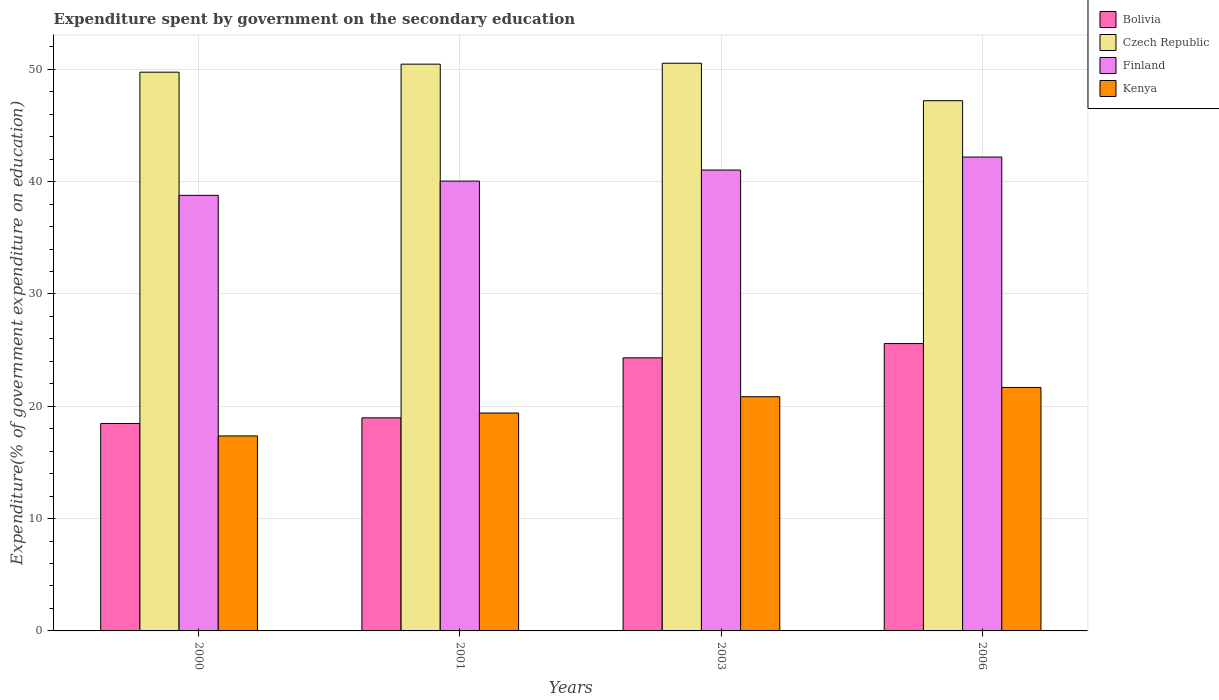How many groups of bars are there?
Offer a very short reply. 4. Are the number of bars per tick equal to the number of legend labels?
Make the answer very short. Yes. Are the number of bars on each tick of the X-axis equal?
Your answer should be very brief. Yes. How many bars are there on the 2nd tick from the left?
Keep it short and to the point. 4. How many bars are there on the 3rd tick from the right?
Offer a terse response. 4. In how many cases, is the number of bars for a given year not equal to the number of legend labels?
Keep it short and to the point. 0. What is the expenditure spent by government on the secondary education in Finland in 2006?
Make the answer very short. 42.19. Across all years, what is the maximum expenditure spent by government on the secondary education in Finland?
Keep it short and to the point. 42.19. Across all years, what is the minimum expenditure spent by government on the secondary education in Finland?
Make the answer very short. 38.78. In which year was the expenditure spent by government on the secondary education in Kenya maximum?
Provide a succinct answer. 2006. In which year was the expenditure spent by government on the secondary education in Finland minimum?
Provide a short and direct response. 2000. What is the total expenditure spent by government on the secondary education in Finland in the graph?
Keep it short and to the point. 162.06. What is the difference between the expenditure spent by government on the secondary education in Finland in 2000 and that in 2006?
Give a very brief answer. -3.41. What is the difference between the expenditure spent by government on the secondary education in Kenya in 2003 and the expenditure spent by government on the secondary education in Czech Republic in 2006?
Offer a terse response. -26.36. What is the average expenditure spent by government on the secondary education in Bolivia per year?
Your answer should be very brief. 21.84. In the year 2000, what is the difference between the expenditure spent by government on the secondary education in Kenya and expenditure spent by government on the secondary education in Finland?
Offer a terse response. -21.42. What is the ratio of the expenditure spent by government on the secondary education in Czech Republic in 2003 to that in 2006?
Your response must be concise. 1.07. What is the difference between the highest and the second highest expenditure spent by government on the secondary education in Bolivia?
Provide a succinct answer. 1.27. What is the difference between the highest and the lowest expenditure spent by government on the secondary education in Finland?
Provide a short and direct response. 3.41. In how many years, is the expenditure spent by government on the secondary education in Kenya greater than the average expenditure spent by government on the secondary education in Kenya taken over all years?
Give a very brief answer. 2. Is the sum of the expenditure spent by government on the secondary education in Finland in 2000 and 2006 greater than the maximum expenditure spent by government on the secondary education in Czech Republic across all years?
Your answer should be compact. Yes. What does the 3rd bar from the left in 2001 represents?
Provide a short and direct response. Finland. What does the 1st bar from the right in 2003 represents?
Offer a terse response. Kenya. How many bars are there?
Keep it short and to the point. 16. Are all the bars in the graph horizontal?
Give a very brief answer. No. How many years are there in the graph?
Keep it short and to the point. 4. Are the values on the major ticks of Y-axis written in scientific E-notation?
Offer a terse response. No. Where does the legend appear in the graph?
Ensure brevity in your answer.  Top right. How many legend labels are there?
Your response must be concise. 4. How are the legend labels stacked?
Offer a terse response. Vertical. What is the title of the graph?
Provide a short and direct response. Expenditure spent by government on the secondary education. Does "Lao PDR" appear as one of the legend labels in the graph?
Keep it short and to the point. No. What is the label or title of the Y-axis?
Your answer should be very brief. Expenditure(% of government expenditure on education). What is the Expenditure(% of government expenditure on education) in Bolivia in 2000?
Offer a very short reply. 18.47. What is the Expenditure(% of government expenditure on education) of Czech Republic in 2000?
Offer a very short reply. 49.75. What is the Expenditure(% of government expenditure on education) of Finland in 2000?
Provide a short and direct response. 38.78. What is the Expenditure(% of government expenditure on education) in Kenya in 2000?
Your response must be concise. 17.36. What is the Expenditure(% of government expenditure on education) of Bolivia in 2001?
Keep it short and to the point. 18.97. What is the Expenditure(% of government expenditure on education) of Czech Republic in 2001?
Keep it short and to the point. 50.46. What is the Expenditure(% of government expenditure on education) in Finland in 2001?
Offer a terse response. 40.05. What is the Expenditure(% of government expenditure on education) in Kenya in 2001?
Your answer should be compact. 19.4. What is the Expenditure(% of government expenditure on education) of Bolivia in 2003?
Keep it short and to the point. 24.32. What is the Expenditure(% of government expenditure on education) of Czech Republic in 2003?
Make the answer very short. 50.54. What is the Expenditure(% of government expenditure on education) in Finland in 2003?
Ensure brevity in your answer.  41.04. What is the Expenditure(% of government expenditure on education) of Kenya in 2003?
Your answer should be very brief. 20.85. What is the Expenditure(% of government expenditure on education) in Bolivia in 2006?
Make the answer very short. 25.59. What is the Expenditure(% of government expenditure on education) of Czech Republic in 2006?
Offer a terse response. 47.21. What is the Expenditure(% of government expenditure on education) in Finland in 2006?
Give a very brief answer. 42.19. What is the Expenditure(% of government expenditure on education) in Kenya in 2006?
Provide a short and direct response. 21.68. Across all years, what is the maximum Expenditure(% of government expenditure on education) in Bolivia?
Offer a terse response. 25.59. Across all years, what is the maximum Expenditure(% of government expenditure on education) in Czech Republic?
Provide a succinct answer. 50.54. Across all years, what is the maximum Expenditure(% of government expenditure on education) in Finland?
Your answer should be compact. 42.19. Across all years, what is the maximum Expenditure(% of government expenditure on education) in Kenya?
Provide a succinct answer. 21.68. Across all years, what is the minimum Expenditure(% of government expenditure on education) of Bolivia?
Provide a succinct answer. 18.47. Across all years, what is the minimum Expenditure(% of government expenditure on education) of Czech Republic?
Provide a succinct answer. 47.21. Across all years, what is the minimum Expenditure(% of government expenditure on education) of Finland?
Provide a succinct answer. 38.78. Across all years, what is the minimum Expenditure(% of government expenditure on education) of Kenya?
Make the answer very short. 17.36. What is the total Expenditure(% of government expenditure on education) of Bolivia in the graph?
Provide a short and direct response. 87.34. What is the total Expenditure(% of government expenditure on education) in Czech Republic in the graph?
Provide a succinct answer. 197.97. What is the total Expenditure(% of government expenditure on education) in Finland in the graph?
Offer a very short reply. 162.06. What is the total Expenditure(% of government expenditure on education) in Kenya in the graph?
Offer a very short reply. 79.29. What is the difference between the Expenditure(% of government expenditure on education) in Bolivia in 2000 and that in 2001?
Your answer should be compact. -0.5. What is the difference between the Expenditure(% of government expenditure on education) in Czech Republic in 2000 and that in 2001?
Provide a short and direct response. -0.72. What is the difference between the Expenditure(% of government expenditure on education) of Finland in 2000 and that in 2001?
Your answer should be very brief. -1.27. What is the difference between the Expenditure(% of government expenditure on education) of Kenya in 2000 and that in 2001?
Offer a terse response. -2.04. What is the difference between the Expenditure(% of government expenditure on education) of Bolivia in 2000 and that in 2003?
Your response must be concise. -5.85. What is the difference between the Expenditure(% of government expenditure on education) of Czech Republic in 2000 and that in 2003?
Your answer should be compact. -0.79. What is the difference between the Expenditure(% of government expenditure on education) in Finland in 2000 and that in 2003?
Your answer should be very brief. -2.25. What is the difference between the Expenditure(% of government expenditure on education) of Kenya in 2000 and that in 2003?
Your response must be concise. -3.49. What is the difference between the Expenditure(% of government expenditure on education) in Bolivia in 2000 and that in 2006?
Your answer should be very brief. -7.12. What is the difference between the Expenditure(% of government expenditure on education) of Czech Republic in 2000 and that in 2006?
Give a very brief answer. 2.54. What is the difference between the Expenditure(% of government expenditure on education) of Finland in 2000 and that in 2006?
Offer a terse response. -3.41. What is the difference between the Expenditure(% of government expenditure on education) in Kenya in 2000 and that in 2006?
Give a very brief answer. -4.32. What is the difference between the Expenditure(% of government expenditure on education) of Bolivia in 2001 and that in 2003?
Keep it short and to the point. -5.34. What is the difference between the Expenditure(% of government expenditure on education) of Czech Republic in 2001 and that in 2003?
Your answer should be very brief. -0.08. What is the difference between the Expenditure(% of government expenditure on education) in Finland in 2001 and that in 2003?
Offer a terse response. -0.98. What is the difference between the Expenditure(% of government expenditure on education) of Kenya in 2001 and that in 2003?
Provide a succinct answer. -1.45. What is the difference between the Expenditure(% of government expenditure on education) in Bolivia in 2001 and that in 2006?
Your answer should be very brief. -6.62. What is the difference between the Expenditure(% of government expenditure on education) of Czech Republic in 2001 and that in 2006?
Ensure brevity in your answer.  3.26. What is the difference between the Expenditure(% of government expenditure on education) of Finland in 2001 and that in 2006?
Keep it short and to the point. -2.14. What is the difference between the Expenditure(% of government expenditure on education) of Kenya in 2001 and that in 2006?
Offer a terse response. -2.28. What is the difference between the Expenditure(% of government expenditure on education) of Bolivia in 2003 and that in 2006?
Make the answer very short. -1.27. What is the difference between the Expenditure(% of government expenditure on education) in Czech Republic in 2003 and that in 2006?
Provide a short and direct response. 3.33. What is the difference between the Expenditure(% of government expenditure on education) of Finland in 2003 and that in 2006?
Keep it short and to the point. -1.16. What is the difference between the Expenditure(% of government expenditure on education) of Kenya in 2003 and that in 2006?
Offer a terse response. -0.83. What is the difference between the Expenditure(% of government expenditure on education) of Bolivia in 2000 and the Expenditure(% of government expenditure on education) of Czech Republic in 2001?
Your response must be concise. -32. What is the difference between the Expenditure(% of government expenditure on education) of Bolivia in 2000 and the Expenditure(% of government expenditure on education) of Finland in 2001?
Your answer should be very brief. -21.58. What is the difference between the Expenditure(% of government expenditure on education) in Bolivia in 2000 and the Expenditure(% of government expenditure on education) in Kenya in 2001?
Make the answer very short. -0.93. What is the difference between the Expenditure(% of government expenditure on education) in Czech Republic in 2000 and the Expenditure(% of government expenditure on education) in Finland in 2001?
Offer a terse response. 9.7. What is the difference between the Expenditure(% of government expenditure on education) in Czech Republic in 2000 and the Expenditure(% of government expenditure on education) in Kenya in 2001?
Offer a terse response. 30.35. What is the difference between the Expenditure(% of government expenditure on education) of Finland in 2000 and the Expenditure(% of government expenditure on education) of Kenya in 2001?
Give a very brief answer. 19.38. What is the difference between the Expenditure(% of government expenditure on education) in Bolivia in 2000 and the Expenditure(% of government expenditure on education) in Czech Republic in 2003?
Provide a succinct answer. -32.08. What is the difference between the Expenditure(% of government expenditure on education) of Bolivia in 2000 and the Expenditure(% of government expenditure on education) of Finland in 2003?
Ensure brevity in your answer.  -22.57. What is the difference between the Expenditure(% of government expenditure on education) of Bolivia in 2000 and the Expenditure(% of government expenditure on education) of Kenya in 2003?
Ensure brevity in your answer.  -2.38. What is the difference between the Expenditure(% of government expenditure on education) in Czech Republic in 2000 and the Expenditure(% of government expenditure on education) in Finland in 2003?
Make the answer very short. 8.71. What is the difference between the Expenditure(% of government expenditure on education) in Czech Republic in 2000 and the Expenditure(% of government expenditure on education) in Kenya in 2003?
Provide a succinct answer. 28.9. What is the difference between the Expenditure(% of government expenditure on education) of Finland in 2000 and the Expenditure(% of government expenditure on education) of Kenya in 2003?
Provide a short and direct response. 17.93. What is the difference between the Expenditure(% of government expenditure on education) of Bolivia in 2000 and the Expenditure(% of government expenditure on education) of Czech Republic in 2006?
Provide a short and direct response. -28.74. What is the difference between the Expenditure(% of government expenditure on education) in Bolivia in 2000 and the Expenditure(% of government expenditure on education) in Finland in 2006?
Your answer should be very brief. -23.73. What is the difference between the Expenditure(% of government expenditure on education) of Bolivia in 2000 and the Expenditure(% of government expenditure on education) of Kenya in 2006?
Your answer should be very brief. -3.21. What is the difference between the Expenditure(% of government expenditure on education) of Czech Republic in 2000 and the Expenditure(% of government expenditure on education) of Finland in 2006?
Ensure brevity in your answer.  7.55. What is the difference between the Expenditure(% of government expenditure on education) of Czech Republic in 2000 and the Expenditure(% of government expenditure on education) of Kenya in 2006?
Keep it short and to the point. 28.07. What is the difference between the Expenditure(% of government expenditure on education) of Finland in 2000 and the Expenditure(% of government expenditure on education) of Kenya in 2006?
Keep it short and to the point. 17.1. What is the difference between the Expenditure(% of government expenditure on education) in Bolivia in 2001 and the Expenditure(% of government expenditure on education) in Czech Republic in 2003?
Your answer should be compact. -31.57. What is the difference between the Expenditure(% of government expenditure on education) in Bolivia in 2001 and the Expenditure(% of government expenditure on education) in Finland in 2003?
Your answer should be very brief. -22.06. What is the difference between the Expenditure(% of government expenditure on education) of Bolivia in 2001 and the Expenditure(% of government expenditure on education) of Kenya in 2003?
Provide a short and direct response. -1.88. What is the difference between the Expenditure(% of government expenditure on education) of Czech Republic in 2001 and the Expenditure(% of government expenditure on education) of Finland in 2003?
Provide a short and direct response. 9.43. What is the difference between the Expenditure(% of government expenditure on education) of Czech Republic in 2001 and the Expenditure(% of government expenditure on education) of Kenya in 2003?
Offer a very short reply. 29.61. What is the difference between the Expenditure(% of government expenditure on education) in Finland in 2001 and the Expenditure(% of government expenditure on education) in Kenya in 2003?
Your answer should be compact. 19.2. What is the difference between the Expenditure(% of government expenditure on education) in Bolivia in 2001 and the Expenditure(% of government expenditure on education) in Czech Republic in 2006?
Offer a very short reply. -28.24. What is the difference between the Expenditure(% of government expenditure on education) of Bolivia in 2001 and the Expenditure(% of government expenditure on education) of Finland in 2006?
Keep it short and to the point. -23.22. What is the difference between the Expenditure(% of government expenditure on education) of Bolivia in 2001 and the Expenditure(% of government expenditure on education) of Kenya in 2006?
Your response must be concise. -2.71. What is the difference between the Expenditure(% of government expenditure on education) in Czech Republic in 2001 and the Expenditure(% of government expenditure on education) in Finland in 2006?
Your answer should be compact. 8.27. What is the difference between the Expenditure(% of government expenditure on education) of Czech Republic in 2001 and the Expenditure(% of government expenditure on education) of Kenya in 2006?
Offer a terse response. 28.79. What is the difference between the Expenditure(% of government expenditure on education) in Finland in 2001 and the Expenditure(% of government expenditure on education) in Kenya in 2006?
Offer a very short reply. 18.37. What is the difference between the Expenditure(% of government expenditure on education) in Bolivia in 2003 and the Expenditure(% of government expenditure on education) in Czech Republic in 2006?
Give a very brief answer. -22.89. What is the difference between the Expenditure(% of government expenditure on education) in Bolivia in 2003 and the Expenditure(% of government expenditure on education) in Finland in 2006?
Your answer should be very brief. -17.88. What is the difference between the Expenditure(% of government expenditure on education) in Bolivia in 2003 and the Expenditure(% of government expenditure on education) in Kenya in 2006?
Your response must be concise. 2.64. What is the difference between the Expenditure(% of government expenditure on education) in Czech Republic in 2003 and the Expenditure(% of government expenditure on education) in Finland in 2006?
Offer a very short reply. 8.35. What is the difference between the Expenditure(% of government expenditure on education) in Czech Republic in 2003 and the Expenditure(% of government expenditure on education) in Kenya in 2006?
Provide a short and direct response. 28.87. What is the difference between the Expenditure(% of government expenditure on education) in Finland in 2003 and the Expenditure(% of government expenditure on education) in Kenya in 2006?
Your answer should be compact. 19.36. What is the average Expenditure(% of government expenditure on education) of Bolivia per year?
Ensure brevity in your answer.  21.84. What is the average Expenditure(% of government expenditure on education) in Czech Republic per year?
Provide a succinct answer. 49.49. What is the average Expenditure(% of government expenditure on education) of Finland per year?
Your answer should be very brief. 40.52. What is the average Expenditure(% of government expenditure on education) in Kenya per year?
Offer a terse response. 19.82. In the year 2000, what is the difference between the Expenditure(% of government expenditure on education) of Bolivia and Expenditure(% of government expenditure on education) of Czech Republic?
Give a very brief answer. -31.28. In the year 2000, what is the difference between the Expenditure(% of government expenditure on education) in Bolivia and Expenditure(% of government expenditure on education) in Finland?
Your answer should be very brief. -20.31. In the year 2000, what is the difference between the Expenditure(% of government expenditure on education) of Bolivia and Expenditure(% of government expenditure on education) of Kenya?
Make the answer very short. 1.11. In the year 2000, what is the difference between the Expenditure(% of government expenditure on education) in Czech Republic and Expenditure(% of government expenditure on education) in Finland?
Make the answer very short. 10.97. In the year 2000, what is the difference between the Expenditure(% of government expenditure on education) in Czech Republic and Expenditure(% of government expenditure on education) in Kenya?
Your answer should be very brief. 32.39. In the year 2000, what is the difference between the Expenditure(% of government expenditure on education) in Finland and Expenditure(% of government expenditure on education) in Kenya?
Ensure brevity in your answer.  21.42. In the year 2001, what is the difference between the Expenditure(% of government expenditure on education) of Bolivia and Expenditure(% of government expenditure on education) of Czech Republic?
Keep it short and to the point. -31.49. In the year 2001, what is the difference between the Expenditure(% of government expenditure on education) of Bolivia and Expenditure(% of government expenditure on education) of Finland?
Your answer should be compact. -21.08. In the year 2001, what is the difference between the Expenditure(% of government expenditure on education) of Bolivia and Expenditure(% of government expenditure on education) of Kenya?
Make the answer very short. -0.43. In the year 2001, what is the difference between the Expenditure(% of government expenditure on education) in Czech Republic and Expenditure(% of government expenditure on education) in Finland?
Keep it short and to the point. 10.41. In the year 2001, what is the difference between the Expenditure(% of government expenditure on education) of Czech Republic and Expenditure(% of government expenditure on education) of Kenya?
Offer a terse response. 31.06. In the year 2001, what is the difference between the Expenditure(% of government expenditure on education) in Finland and Expenditure(% of government expenditure on education) in Kenya?
Your response must be concise. 20.65. In the year 2003, what is the difference between the Expenditure(% of government expenditure on education) in Bolivia and Expenditure(% of government expenditure on education) in Czech Republic?
Your answer should be very brief. -26.23. In the year 2003, what is the difference between the Expenditure(% of government expenditure on education) in Bolivia and Expenditure(% of government expenditure on education) in Finland?
Your answer should be compact. -16.72. In the year 2003, what is the difference between the Expenditure(% of government expenditure on education) of Bolivia and Expenditure(% of government expenditure on education) of Kenya?
Your answer should be compact. 3.46. In the year 2003, what is the difference between the Expenditure(% of government expenditure on education) of Czech Republic and Expenditure(% of government expenditure on education) of Finland?
Keep it short and to the point. 9.51. In the year 2003, what is the difference between the Expenditure(% of government expenditure on education) of Czech Republic and Expenditure(% of government expenditure on education) of Kenya?
Provide a succinct answer. 29.69. In the year 2003, what is the difference between the Expenditure(% of government expenditure on education) of Finland and Expenditure(% of government expenditure on education) of Kenya?
Your answer should be very brief. 20.18. In the year 2006, what is the difference between the Expenditure(% of government expenditure on education) of Bolivia and Expenditure(% of government expenditure on education) of Czech Republic?
Give a very brief answer. -21.62. In the year 2006, what is the difference between the Expenditure(% of government expenditure on education) in Bolivia and Expenditure(% of government expenditure on education) in Finland?
Provide a succinct answer. -16.61. In the year 2006, what is the difference between the Expenditure(% of government expenditure on education) in Bolivia and Expenditure(% of government expenditure on education) in Kenya?
Provide a succinct answer. 3.91. In the year 2006, what is the difference between the Expenditure(% of government expenditure on education) in Czech Republic and Expenditure(% of government expenditure on education) in Finland?
Give a very brief answer. 5.02. In the year 2006, what is the difference between the Expenditure(% of government expenditure on education) in Czech Republic and Expenditure(% of government expenditure on education) in Kenya?
Your answer should be compact. 25.53. In the year 2006, what is the difference between the Expenditure(% of government expenditure on education) in Finland and Expenditure(% of government expenditure on education) in Kenya?
Offer a terse response. 20.52. What is the ratio of the Expenditure(% of government expenditure on education) in Bolivia in 2000 to that in 2001?
Make the answer very short. 0.97. What is the ratio of the Expenditure(% of government expenditure on education) of Czech Republic in 2000 to that in 2001?
Offer a very short reply. 0.99. What is the ratio of the Expenditure(% of government expenditure on education) of Finland in 2000 to that in 2001?
Offer a very short reply. 0.97. What is the ratio of the Expenditure(% of government expenditure on education) in Kenya in 2000 to that in 2001?
Your answer should be very brief. 0.89. What is the ratio of the Expenditure(% of government expenditure on education) of Bolivia in 2000 to that in 2003?
Provide a succinct answer. 0.76. What is the ratio of the Expenditure(% of government expenditure on education) in Czech Republic in 2000 to that in 2003?
Provide a short and direct response. 0.98. What is the ratio of the Expenditure(% of government expenditure on education) of Finland in 2000 to that in 2003?
Provide a succinct answer. 0.95. What is the ratio of the Expenditure(% of government expenditure on education) of Kenya in 2000 to that in 2003?
Your response must be concise. 0.83. What is the ratio of the Expenditure(% of government expenditure on education) of Bolivia in 2000 to that in 2006?
Make the answer very short. 0.72. What is the ratio of the Expenditure(% of government expenditure on education) of Czech Republic in 2000 to that in 2006?
Make the answer very short. 1.05. What is the ratio of the Expenditure(% of government expenditure on education) in Finland in 2000 to that in 2006?
Provide a succinct answer. 0.92. What is the ratio of the Expenditure(% of government expenditure on education) in Kenya in 2000 to that in 2006?
Ensure brevity in your answer.  0.8. What is the ratio of the Expenditure(% of government expenditure on education) of Bolivia in 2001 to that in 2003?
Give a very brief answer. 0.78. What is the ratio of the Expenditure(% of government expenditure on education) in Kenya in 2001 to that in 2003?
Offer a terse response. 0.93. What is the ratio of the Expenditure(% of government expenditure on education) of Bolivia in 2001 to that in 2006?
Provide a succinct answer. 0.74. What is the ratio of the Expenditure(% of government expenditure on education) of Czech Republic in 2001 to that in 2006?
Ensure brevity in your answer.  1.07. What is the ratio of the Expenditure(% of government expenditure on education) of Finland in 2001 to that in 2006?
Your answer should be very brief. 0.95. What is the ratio of the Expenditure(% of government expenditure on education) of Kenya in 2001 to that in 2006?
Provide a short and direct response. 0.9. What is the ratio of the Expenditure(% of government expenditure on education) of Bolivia in 2003 to that in 2006?
Your answer should be compact. 0.95. What is the ratio of the Expenditure(% of government expenditure on education) of Czech Republic in 2003 to that in 2006?
Offer a very short reply. 1.07. What is the ratio of the Expenditure(% of government expenditure on education) in Finland in 2003 to that in 2006?
Your answer should be compact. 0.97. What is the ratio of the Expenditure(% of government expenditure on education) in Kenya in 2003 to that in 2006?
Make the answer very short. 0.96. What is the difference between the highest and the second highest Expenditure(% of government expenditure on education) of Bolivia?
Offer a very short reply. 1.27. What is the difference between the highest and the second highest Expenditure(% of government expenditure on education) in Czech Republic?
Make the answer very short. 0.08. What is the difference between the highest and the second highest Expenditure(% of government expenditure on education) in Finland?
Offer a very short reply. 1.16. What is the difference between the highest and the second highest Expenditure(% of government expenditure on education) of Kenya?
Give a very brief answer. 0.83. What is the difference between the highest and the lowest Expenditure(% of government expenditure on education) of Bolivia?
Make the answer very short. 7.12. What is the difference between the highest and the lowest Expenditure(% of government expenditure on education) in Czech Republic?
Ensure brevity in your answer.  3.33. What is the difference between the highest and the lowest Expenditure(% of government expenditure on education) in Finland?
Offer a very short reply. 3.41. What is the difference between the highest and the lowest Expenditure(% of government expenditure on education) of Kenya?
Provide a succinct answer. 4.32. 